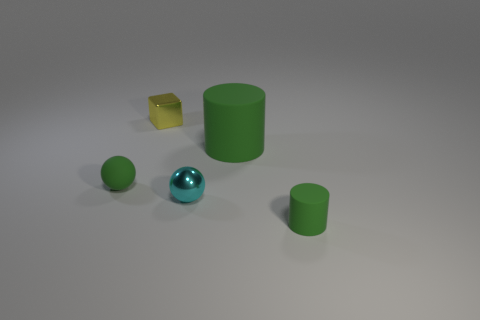There is a green cylinder in front of the small cyan metal ball; what is it made of?
Keep it short and to the point. Rubber. Are there fewer spheres that are behind the large green matte thing than yellow metallic cubes?
Ensure brevity in your answer.  Yes. What shape is the tiny green matte thing behind the tiny sphere that is in front of the small green sphere?
Provide a short and direct response. Sphere. What is the color of the big cylinder?
Offer a very short reply. Green. What number of other things are there of the same size as the cube?
Your response must be concise. 3. There is a thing that is both behind the tiny rubber sphere and on the left side of the cyan object; what material is it?
Make the answer very short. Metal. Is the size of the metallic thing that is right of the yellow block the same as the tiny green matte cylinder?
Keep it short and to the point. Yes. Is the big thing the same color as the matte sphere?
Provide a succinct answer. Yes. How many tiny things are behind the large green rubber cylinder and to the left of the tiny metal block?
Keep it short and to the point. 0. How many cyan balls are behind the tiny green rubber object left of the small object on the right side of the tiny shiny ball?
Your answer should be very brief. 0. 